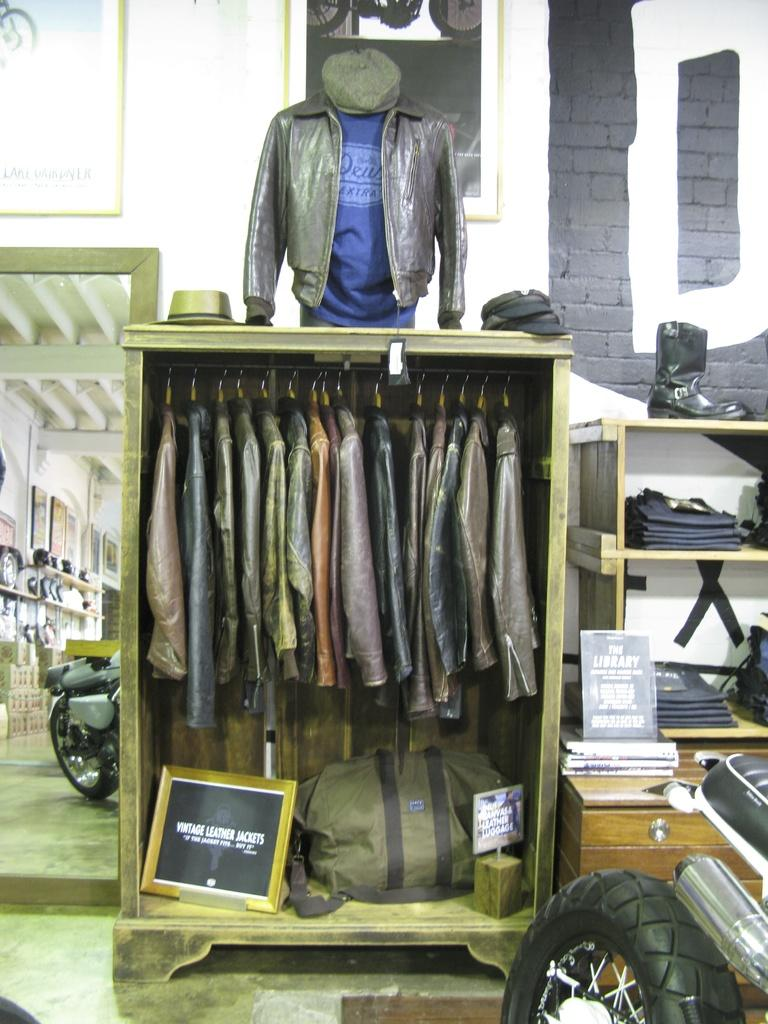What type of clothing is stored on shelves in the image? There are coats on shelves in the image. How are some of the coats hung in the image? Some coats are hanged on hangers in the image. What reflective object is present in the image? There is a mirror in the image. What type of art is displayed on the wire in the image? There is no wire or art present in the image. 